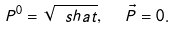<formula> <loc_0><loc_0><loc_500><loc_500>P ^ { 0 } = \sqrt { \ s h a t } , \ \ { \vec { P } } = 0 .</formula> 